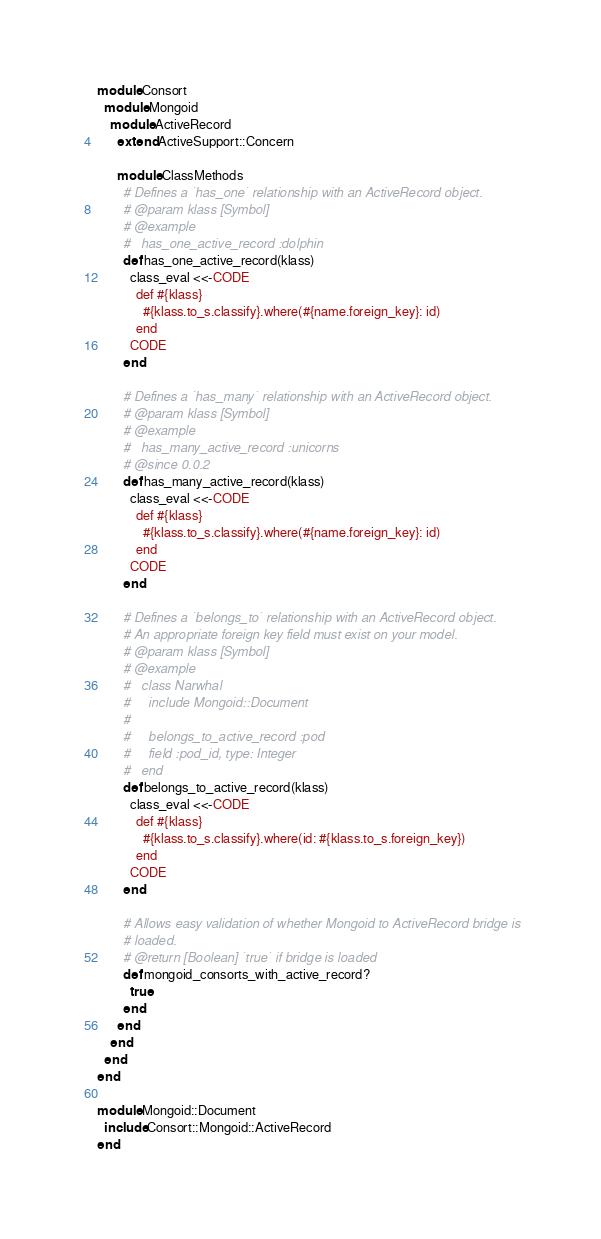Convert code to text. <code><loc_0><loc_0><loc_500><loc_500><_Ruby_>module Consort
  module Mongoid
    module ActiveRecord
      extend ActiveSupport::Concern

      module ClassMethods
        # Defines a `has_one` relationship with an ActiveRecord object.
        # @param klass [Symbol]
        # @example
        #   has_one_active_record :dolphin
        def has_one_active_record(klass)
          class_eval <<-CODE
            def #{klass}
              #{klass.to_s.classify}.where(#{name.foreign_key}: id)
            end
          CODE
        end

        # Defines a `has_many` relationship with an ActiveRecord object.
        # @param klass [Symbol]
        # @example
        #   has_many_active_record :unicorns
        # @since 0.0.2
        def has_many_active_record(klass)
          class_eval <<-CODE
            def #{klass}
              #{klass.to_s.classify}.where(#{name.foreign_key}: id)
            end
          CODE
        end

        # Defines a `belongs_to` relationship with an ActiveRecord object.
        # An appropriate foreign key field must exist on your model.
        # @param klass [Symbol]
        # @example
        #   class Narwhal
        #     include Mongoid::Document
        #
        #     belongs_to_active_record :pod
        #     field :pod_id, type: Integer
        #   end
        def belongs_to_active_record(klass)
          class_eval <<-CODE
            def #{klass}
              #{klass.to_s.classify}.where(id: #{klass.to_s.foreign_key})
            end
          CODE
        end

        # Allows easy validation of whether Mongoid to ActiveRecord bridge is
        # loaded.
        # @return [Boolean] `true` if bridge is loaded
        def mongoid_consorts_with_active_record?
          true
        end
      end
    end
  end
end

module Mongoid::Document
  include Consort::Mongoid::ActiveRecord
end
</code> 